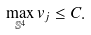Convert formula to latex. <formula><loc_0><loc_0><loc_500><loc_500>\max _ { \mathbb { S } ^ { 4 } } v _ { j } \leq C .</formula> 